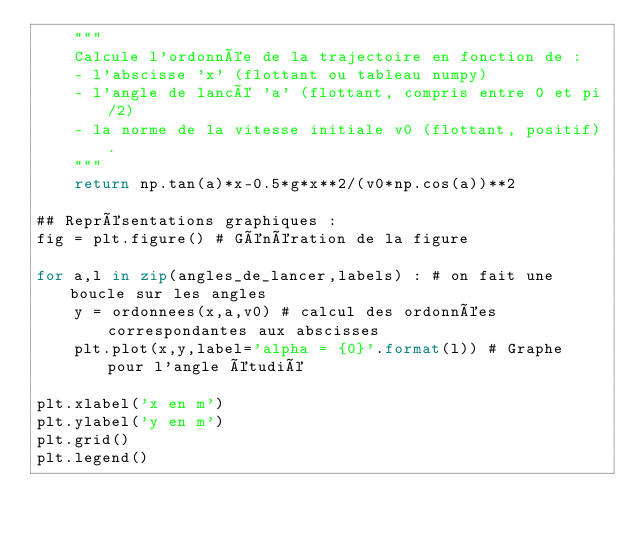<code> <loc_0><loc_0><loc_500><loc_500><_Python_>    """
    Calcule l'ordonnée de la trajectoire en fonction de :
    - l'abscisse 'x' (flottant ou tableau numpy)
    - l'angle de lancé 'a' (flottant, compris entre 0 et pi/2)
    - la norme de la vitesse initiale v0 (flottant, positif).
    """
    return np.tan(a)*x-0.5*g*x**2/(v0*np.cos(a))**2

## Représentations graphiques :
fig = plt.figure() # Génération de la figure

for a,l in zip(angles_de_lancer,labels) : # on fait une boucle sur les angles
    y = ordonnees(x,a,v0) # calcul des ordonnées correspondantes aux abscisses
    plt.plot(x,y,label='alpha = {0}'.format(l)) # Graphe pour l'angle étudié

plt.xlabel('x en m')
plt.ylabel('y en m')
plt.grid()
plt.legend()
</code> 